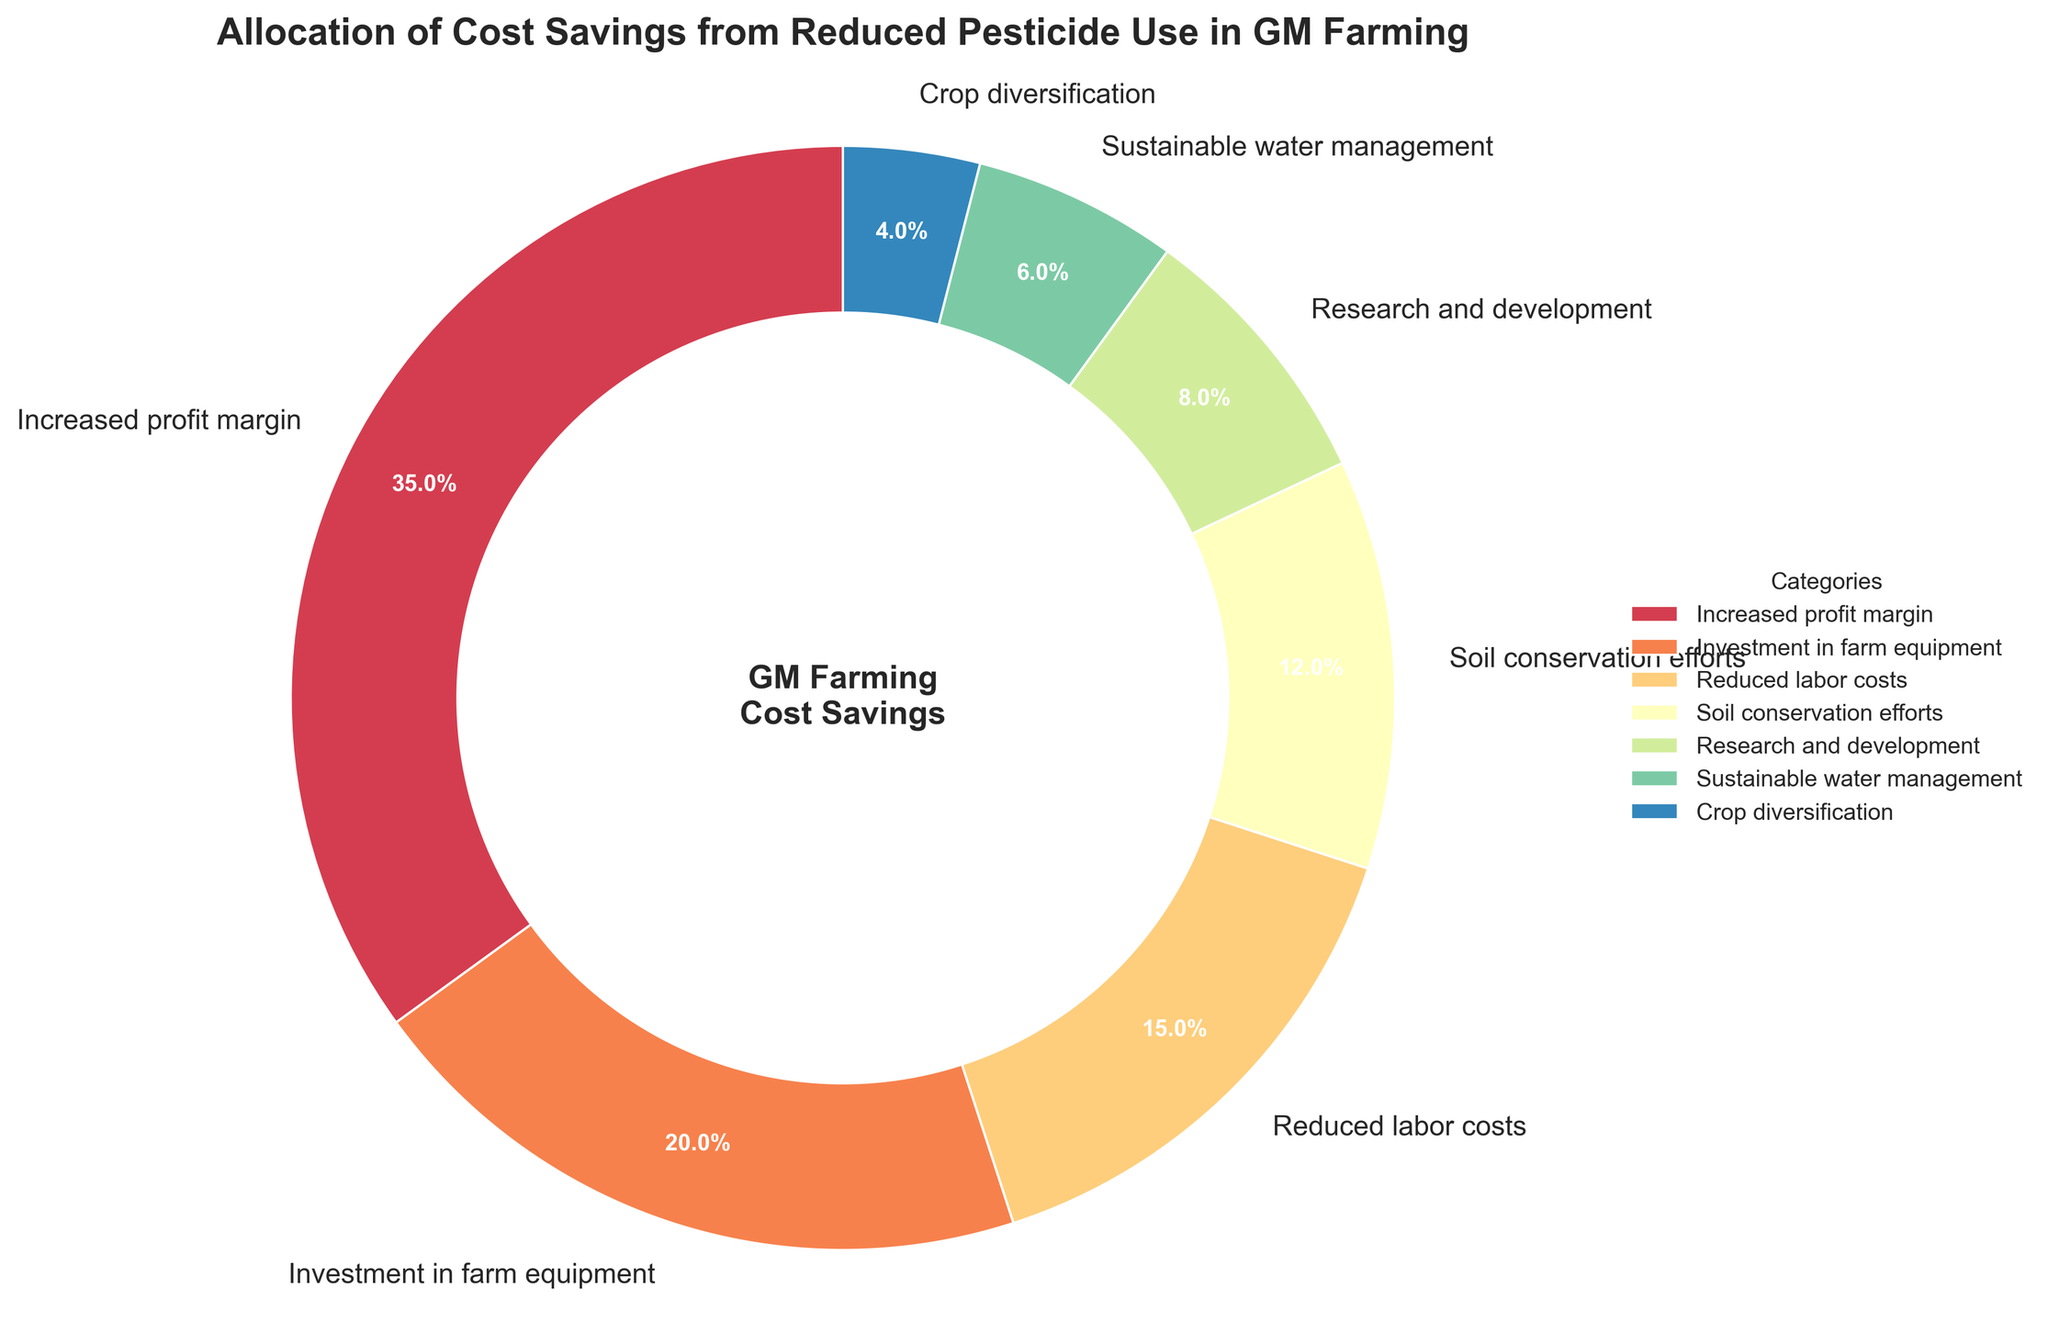What's the largest portion of cost savings allocation? The largest portion of the pie chart represents "Increased profit margin" which is labeled with a percentage larger than the others.
Answer: Increased profit margin What percentage of cost savings is allocated to soil conservation efforts? On the pie chart, the segment labeled "Soil conservation efforts" shows a percentage value.
Answer: 12% How does the allocation for research and development compare to sustainable water management? The pie chart shows that "Research and development" has a percentage of 8%, while "Sustainable water management" has a percentage of 6%. Comparing these values, 8% is greater than 6%.
Answer: Research and development > Sustainable water management What is the combined percentage for investment in farm equipment and reduced labor costs? According to the pie chart, "Investment in farm equipment" is 20% and "Reduced labor costs" is 15%. Adding these together, 20% + 15% = 35%.
Answer: 35% Which category receives the smallest portion of the cost savings? The smallest portion on the pie chart is labeled "Crop diversification" with a percentage.
Answer: Crop diversification How much more is allocated to increased profit margin than to soil conservation efforts? The pie chart shows "Increased profit margin" is 35% and "Soil conservation efforts" is 12%. Subtracting these, 35% - 12% = 23%.
Answer: 23% What is the average percentage allocated to sustainable water management and crop diversification? The pie chart shows "Sustainable water management" has 6% and "Crop diversification" has 4%. Adding these and dividing by 2, (6% + 4%) / 2 = 5%.
Answer: 5% If you combine the allocation percentages for research and development, sustainable water management, and crop diversification, what is the total? The pie chart provides the percentages for "Research and development" (8%), "Sustainable water management" (6%), and "Crop diversification" (4%). Adding these, 8% + 6% + 4% = 18%.
Answer: 18% Which category receives a greater percentage allocation: reduced labor costs or soil conservation efforts? "Reduced labor costs" is 15% and "Soil conservation efforts" is 12% according to the pie chart. Comparing these, 15% is greater than 12%.
Answer: Reduced labor costs What is the sum of the allocations for categories that receive less than 10%? The categories with less than 10% are "Research and development" (8%), "Sustainable water management" (6%), and "Crop diversification" (4%). Adding these, 8% + 6% + 4% = 18%.
Answer: 18% 